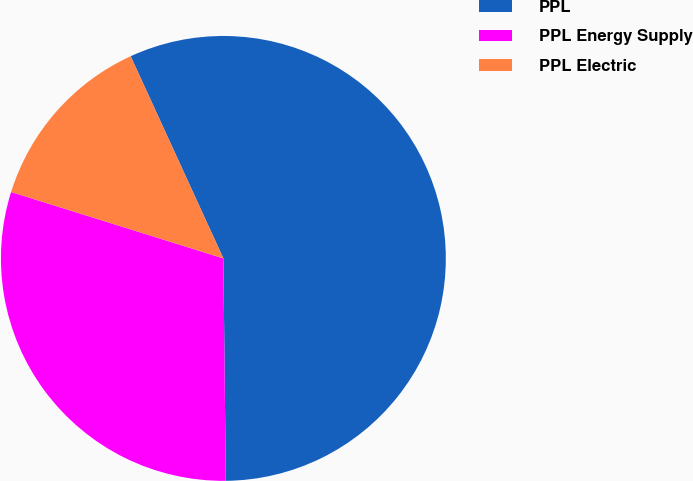<chart> <loc_0><loc_0><loc_500><loc_500><pie_chart><fcel>PPL<fcel>PPL Energy Supply<fcel>PPL Electric<nl><fcel>56.67%<fcel>30.0%<fcel>13.33%<nl></chart> 